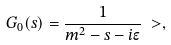<formula> <loc_0><loc_0><loc_500><loc_500>G _ { 0 } ( s ) & = \frac { 1 } { m ^ { 2 } - s - i \epsilon } \ > ,</formula> 